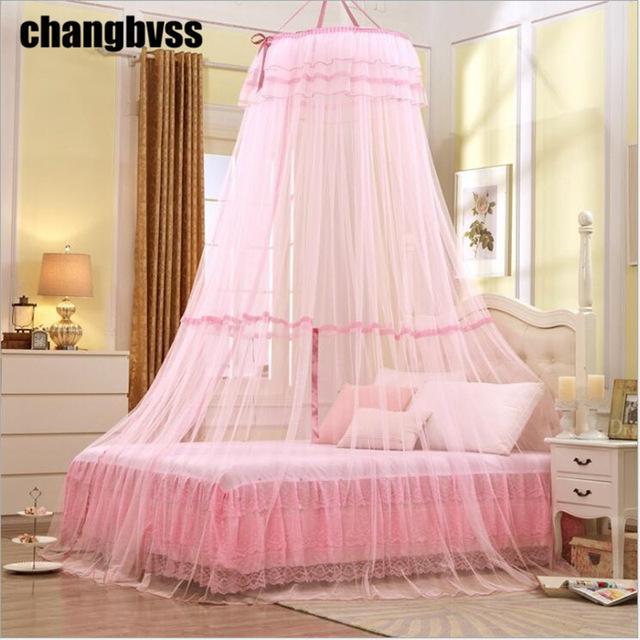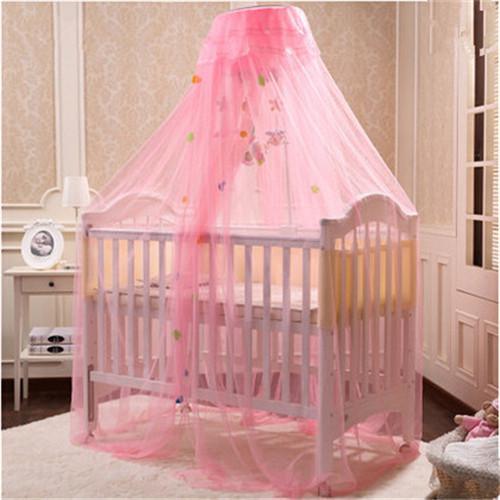The first image is the image on the left, the second image is the image on the right. Examine the images to the left and right. Is the description "An image shows a sheer pink canopy that drapes a bed without rails and with an arched headboard from a cone shape suspended from the ceiling." accurate? Answer yes or no. Yes. The first image is the image on the left, the second image is the image on the right. Evaluate the accuracy of this statement regarding the images: "All the netting is pink.". Is it true? Answer yes or no. Yes. 